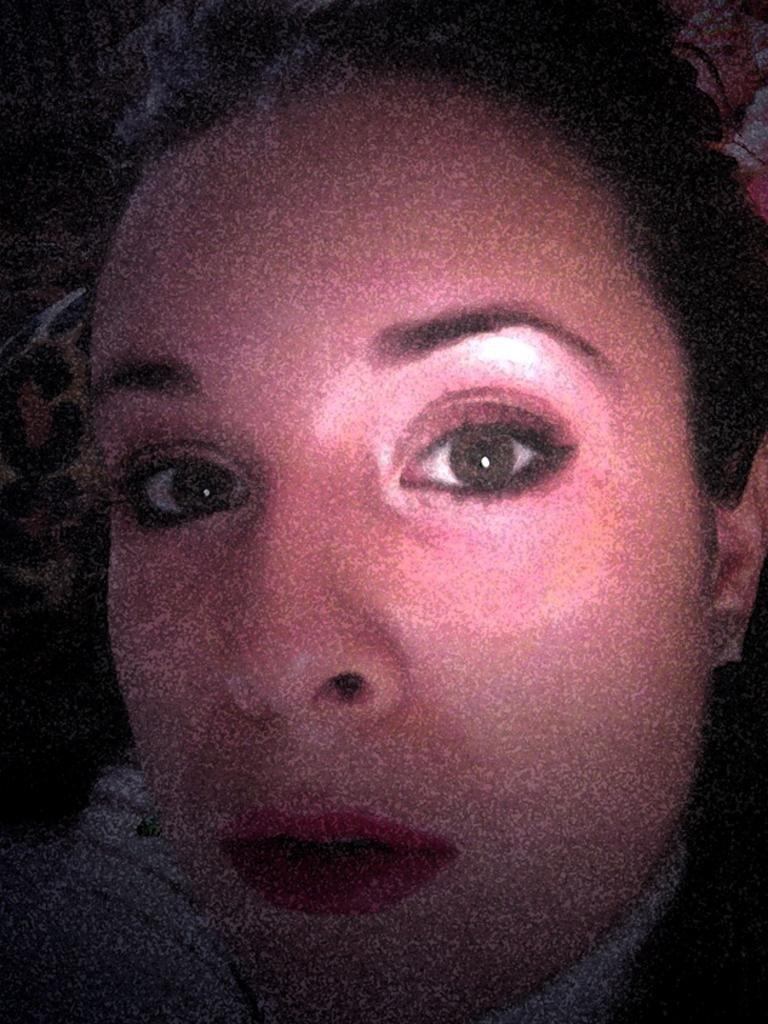What is the main subject of the image? There is a person's face in the image. What riddle is the person's face trying to solve in the image? There is no riddle present in the image; it simply features a person's face. 